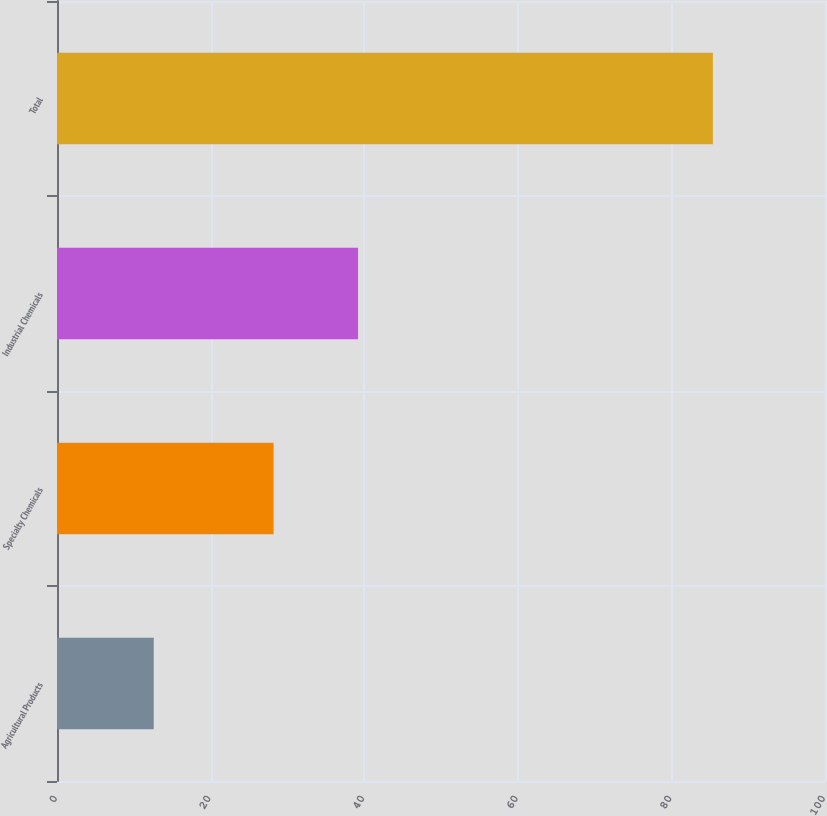Convert chart. <chart><loc_0><loc_0><loc_500><loc_500><bar_chart><fcel>Agricultural Products<fcel>Specialty Chemicals<fcel>Industrial Chemicals<fcel>Total<nl><fcel>12.6<fcel>28.2<fcel>39.2<fcel>85.4<nl></chart> 